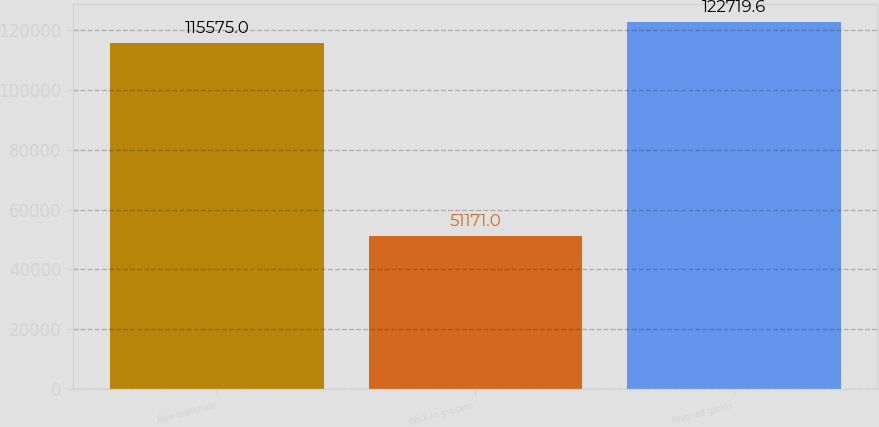<chart> <loc_0><loc_0><loc_500><loc_500><bar_chart><fcel>Raw materials<fcel>Work-in-process<fcel>Finished goods<nl><fcel>115575<fcel>51171<fcel>122720<nl></chart> 